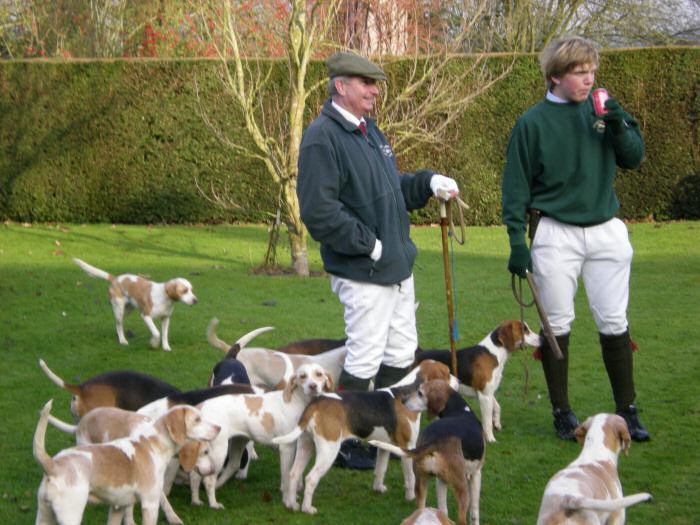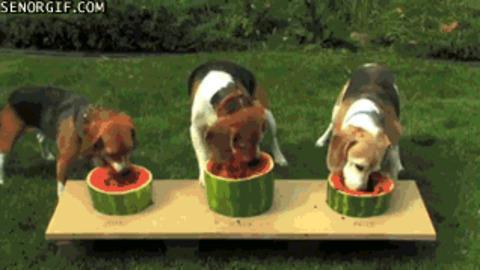The first image is the image on the left, the second image is the image on the right. Analyze the images presented: Is the assertion "An image shows two people wearing white trousers standing by a pack of hound dogs." valid? Answer yes or no. Yes. The first image is the image on the left, the second image is the image on the right. Given the left and right images, does the statement "In one image, two people wearing white pants and dark tops, and carrying dog handling equipment are standing with a pack of dogs." hold true? Answer yes or no. Yes. 